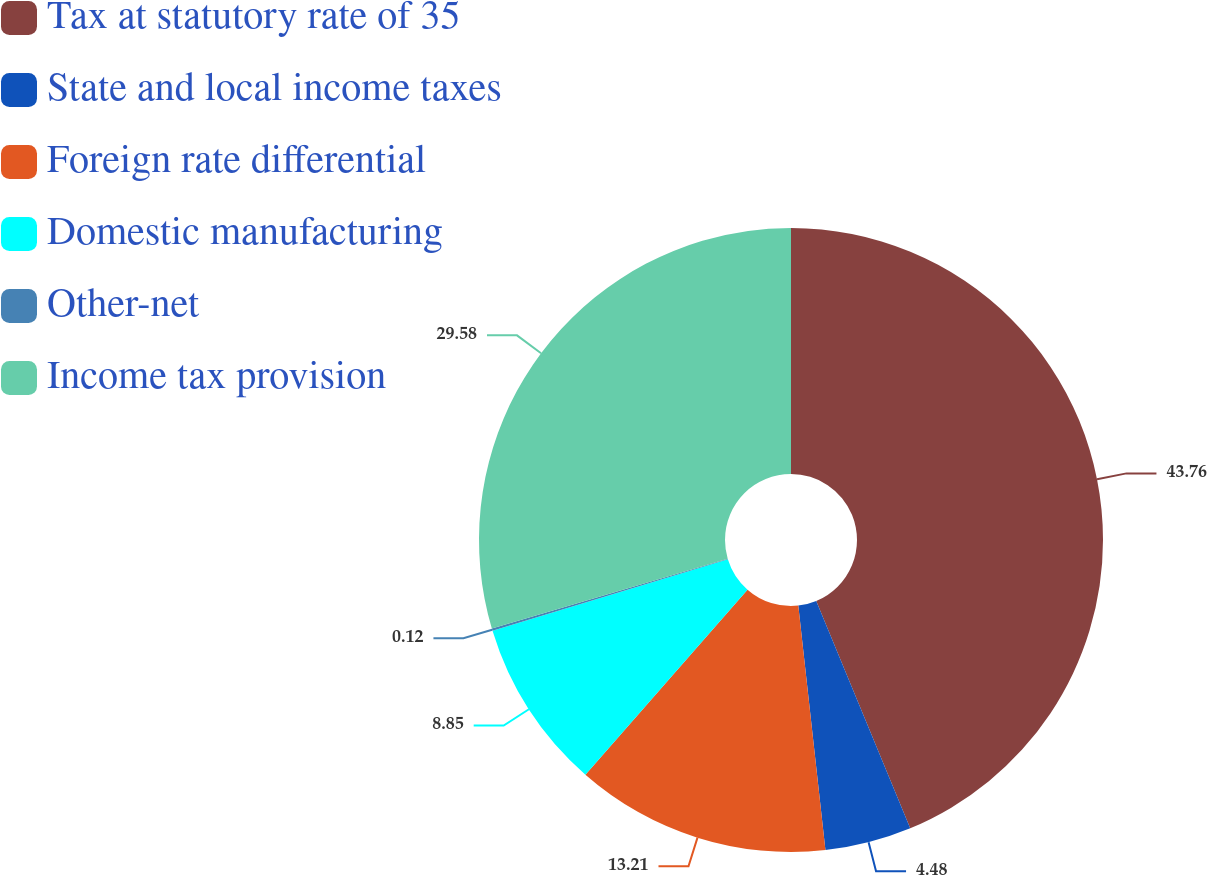<chart> <loc_0><loc_0><loc_500><loc_500><pie_chart><fcel>Tax at statutory rate of 35<fcel>State and local income taxes<fcel>Foreign rate differential<fcel>Domestic manufacturing<fcel>Other-net<fcel>Income tax provision<nl><fcel>43.76%<fcel>4.48%<fcel>13.21%<fcel>8.85%<fcel>0.12%<fcel>29.58%<nl></chart> 